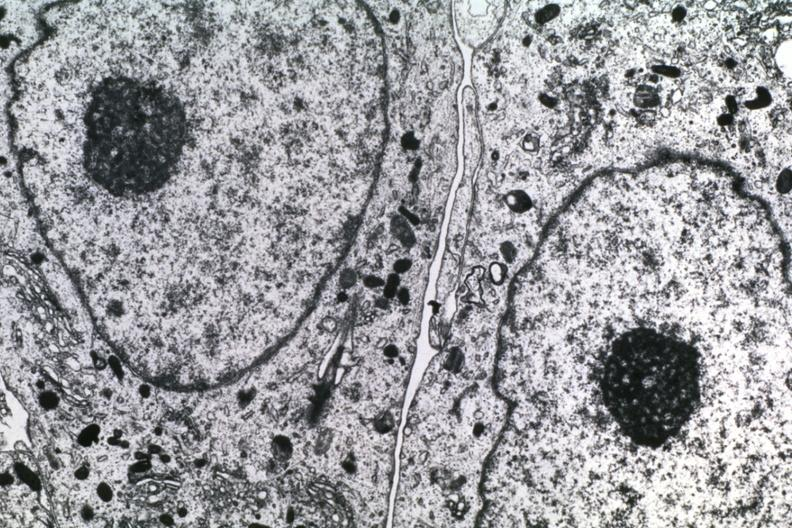what is present?
Answer the question using a single word or phrase. Brain 